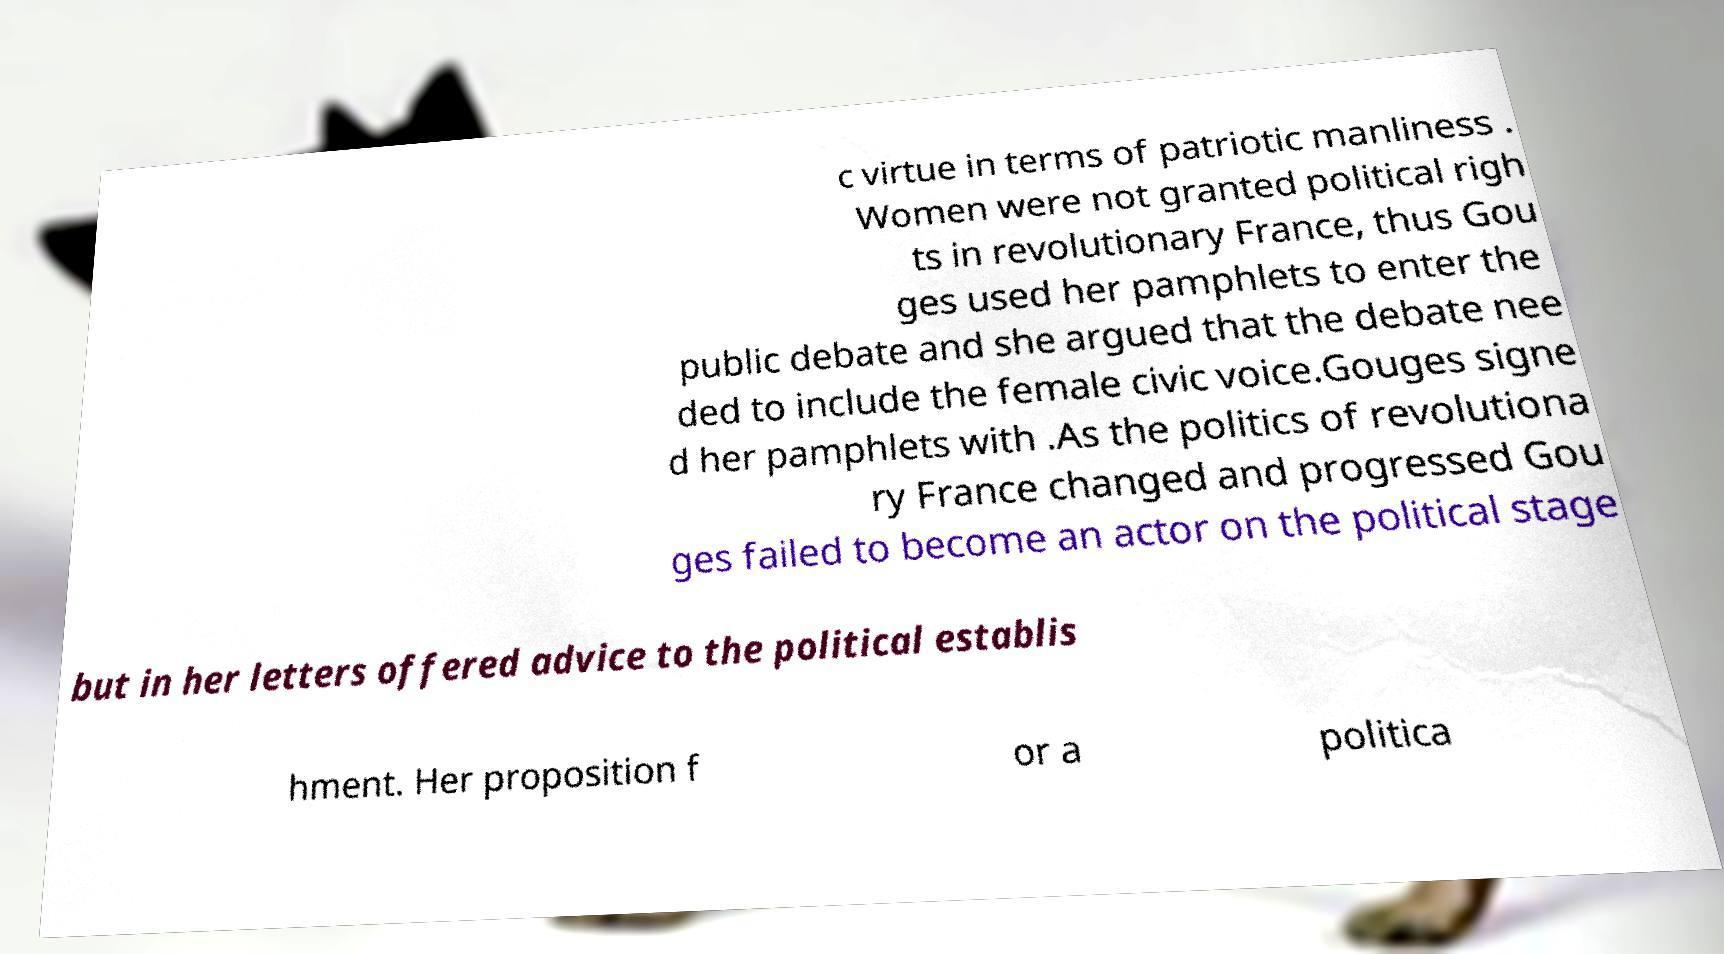Could you assist in decoding the text presented in this image and type it out clearly? c virtue in terms of patriotic manliness . Women were not granted political righ ts in revolutionary France, thus Gou ges used her pamphlets to enter the public debate and she argued that the debate nee ded to include the female civic voice.Gouges signe d her pamphlets with .As the politics of revolutiona ry France changed and progressed Gou ges failed to become an actor on the political stage but in her letters offered advice to the political establis hment. Her proposition f or a politica 